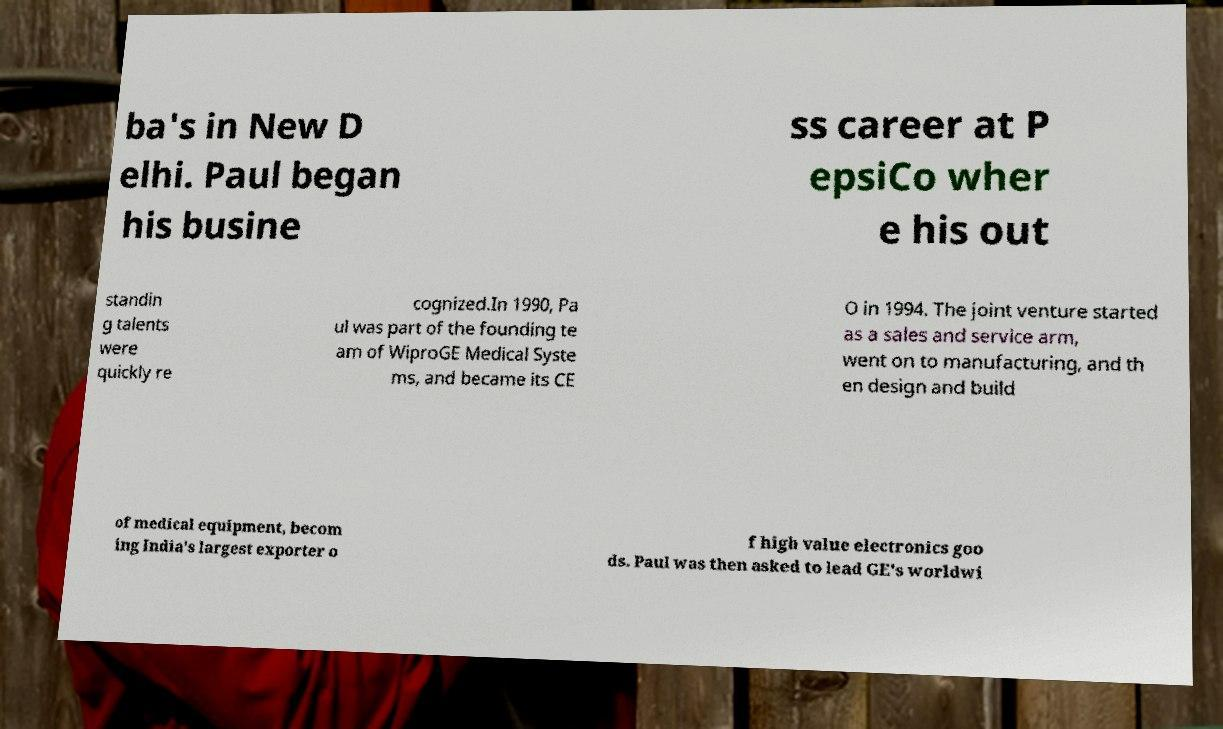Can you accurately transcribe the text from the provided image for me? ba's in New D elhi. Paul began his busine ss career at P epsiCo wher e his out standin g talents were quickly re cognized.In 1990, Pa ul was part of the founding te am of WiproGE Medical Syste ms, and became its CE O in 1994. The joint venture started as a sales and service arm, went on to manufacturing, and th en design and build of medical equipment, becom ing India's largest exporter o f high value electronics goo ds. Paul was then asked to lead GE's worldwi 